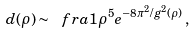<formula> <loc_0><loc_0><loc_500><loc_500>d ( \rho ) \sim \ f r a { 1 } { \rho ^ { 5 } } e ^ { - 8 \pi ^ { 2 } / g ^ { 2 } ( \rho ) } \, ,</formula> 